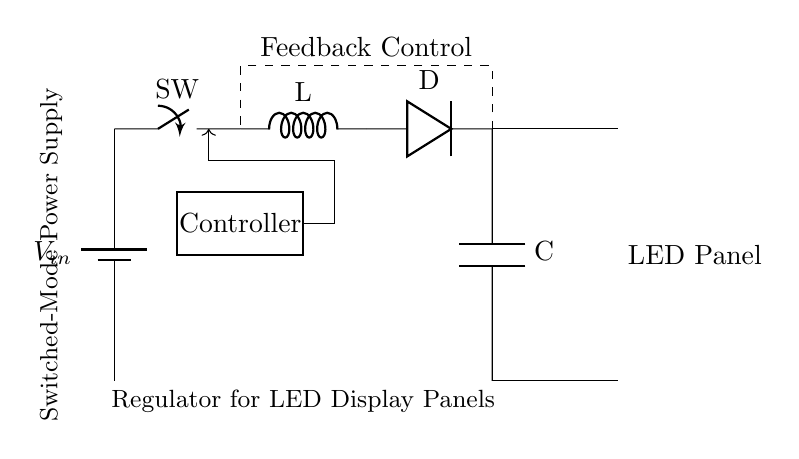What is the input voltage of the circuit? The circuit shows a battery labeled as V_{in}, indicating it is the input voltage source. There is no specific value mentioned for V_{in}, hence it is a variable.
Answer: V_{in} What component controls the switching in the circuit? The circuit diagram includes a switch labeled SW, which indicates it is responsible for controlling the flow of current through the circuit when it is opened or closed.
Answer: Switch What is the function of the inductor in this circuit? The inductor labeled L stores energy in a magnetic field when current flows through it. In this power supply design, it aids in regulating the output voltage.
Answer: Energy storage What is the role of the diode in the circuit? The diode labeled D allows current to flow in one direction only, preventing backflow, which is essential in maintaining a stable output for the LED display panels.
Answer: Prevents backflow What does the dashed line represent in the circuit? The dashed line represents the feedback control loop that monitors the output voltage and adjusts the duty cycle of the PWM signal to maintain stable output, indicating a feedback system.
Answer: Feedback Control How is the output voltage supplied to the LED panel? The output voltage is supplied through the capacitor labeled C, which smooths the output voltage after the energy has been processed through the diode and inductor.
Answer: Through the capacitor What type of control mechanism is used in this circuit? The control mechanism is a PWM (Pulse Width Modulation) signal, which modulates the voltage to control the power delivered to the LED panel effectively.
Answer: PWM signal 